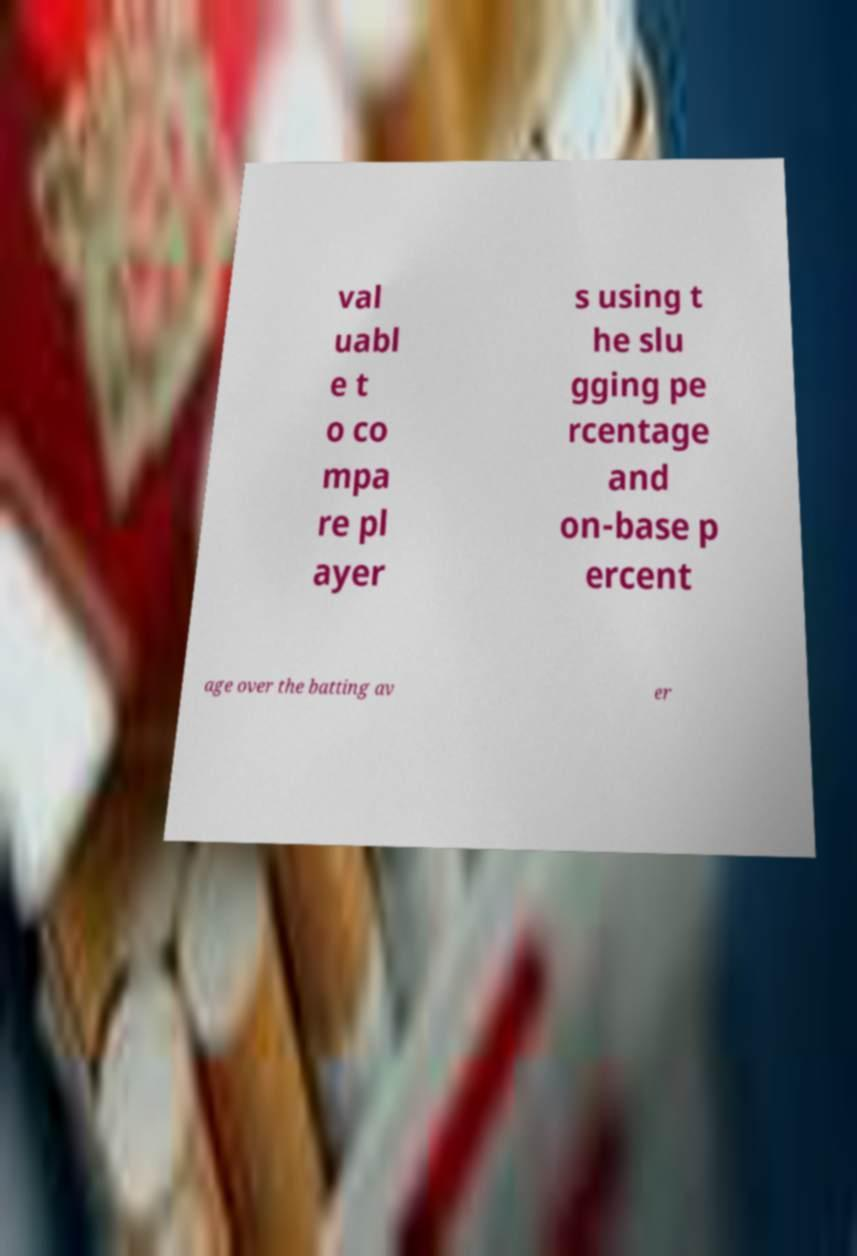What messages or text are displayed in this image? I need them in a readable, typed format. val uabl e t o co mpa re pl ayer s using t he slu gging pe rcentage and on-base p ercent age over the batting av er 